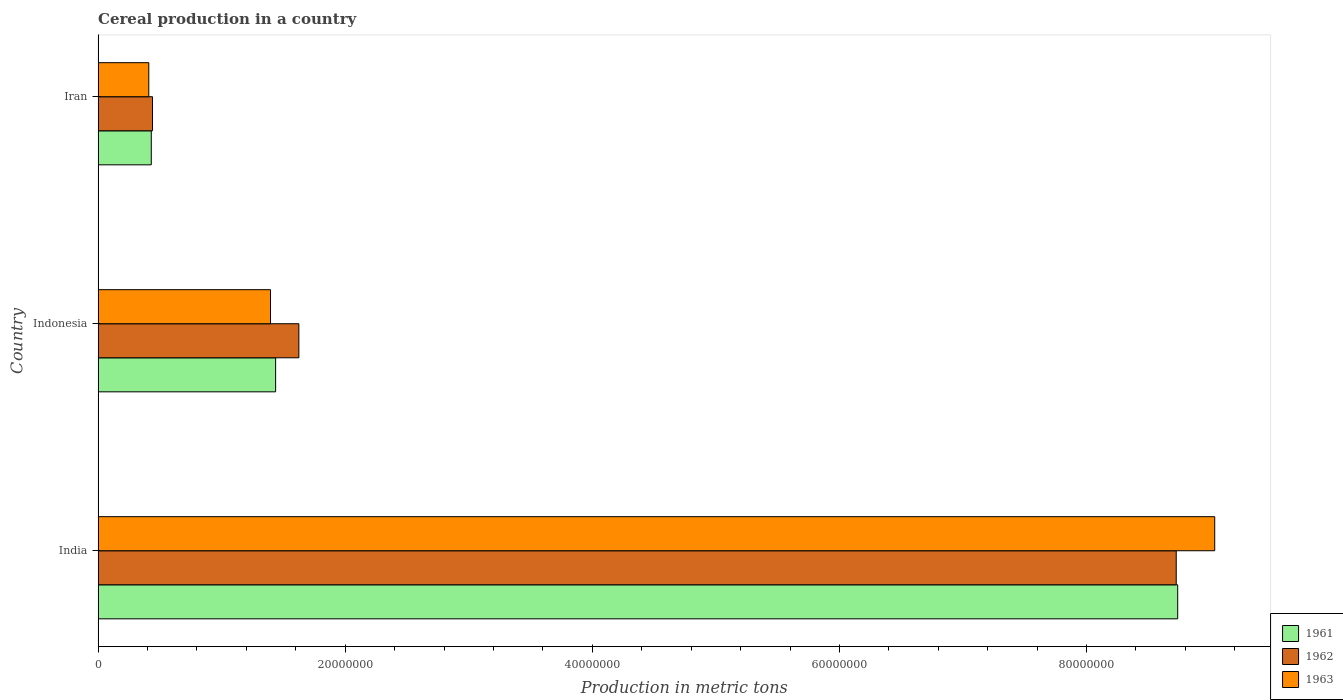How many different coloured bars are there?
Your answer should be very brief. 3. Are the number of bars on each tick of the Y-axis equal?
Provide a succinct answer. Yes. How many bars are there on the 1st tick from the top?
Make the answer very short. 3. How many bars are there on the 2nd tick from the bottom?
Offer a terse response. 3. What is the label of the 3rd group of bars from the top?
Your response must be concise. India. What is the total cereal production in 1961 in India?
Keep it short and to the point. 8.74e+07. Across all countries, what is the maximum total cereal production in 1963?
Provide a short and direct response. 9.04e+07. Across all countries, what is the minimum total cereal production in 1963?
Your answer should be very brief. 4.10e+06. In which country was the total cereal production in 1962 maximum?
Give a very brief answer. India. In which country was the total cereal production in 1962 minimum?
Provide a short and direct response. Iran. What is the total total cereal production in 1962 in the graph?
Your answer should be compact. 1.08e+08. What is the difference between the total cereal production in 1961 in India and that in Indonesia?
Make the answer very short. 7.30e+07. What is the difference between the total cereal production in 1963 in India and the total cereal production in 1962 in Indonesia?
Offer a terse response. 7.41e+07. What is the average total cereal production in 1962 per country?
Your answer should be compact. 3.60e+07. What is the difference between the total cereal production in 1962 and total cereal production in 1961 in India?
Make the answer very short. -1.19e+05. In how many countries, is the total cereal production in 1962 greater than 84000000 metric tons?
Offer a terse response. 1. What is the ratio of the total cereal production in 1963 in India to that in Indonesia?
Your answer should be compact. 6.48. Is the total cereal production in 1961 in India less than that in Indonesia?
Offer a terse response. No. Is the difference between the total cereal production in 1962 in India and Indonesia greater than the difference between the total cereal production in 1961 in India and Indonesia?
Your response must be concise. No. What is the difference between the highest and the second highest total cereal production in 1963?
Give a very brief answer. 7.64e+07. What is the difference between the highest and the lowest total cereal production in 1961?
Keep it short and to the point. 8.31e+07. In how many countries, is the total cereal production in 1962 greater than the average total cereal production in 1962 taken over all countries?
Make the answer very short. 1. Is it the case that in every country, the sum of the total cereal production in 1963 and total cereal production in 1962 is greater than the total cereal production in 1961?
Ensure brevity in your answer.  Yes. Are all the bars in the graph horizontal?
Keep it short and to the point. Yes. What is the difference between two consecutive major ticks on the X-axis?
Your answer should be compact. 2.00e+07. Are the values on the major ticks of X-axis written in scientific E-notation?
Ensure brevity in your answer.  No. Does the graph contain any zero values?
Your response must be concise. No. Where does the legend appear in the graph?
Keep it short and to the point. Bottom right. How are the legend labels stacked?
Keep it short and to the point. Vertical. What is the title of the graph?
Give a very brief answer. Cereal production in a country. What is the label or title of the X-axis?
Your answer should be compact. Production in metric tons. What is the label or title of the Y-axis?
Your answer should be compact. Country. What is the Production in metric tons in 1961 in India?
Your answer should be very brief. 8.74e+07. What is the Production in metric tons in 1962 in India?
Offer a very short reply. 8.73e+07. What is the Production in metric tons in 1963 in India?
Your response must be concise. 9.04e+07. What is the Production in metric tons in 1961 in Indonesia?
Ensure brevity in your answer.  1.44e+07. What is the Production in metric tons in 1962 in Indonesia?
Provide a short and direct response. 1.62e+07. What is the Production in metric tons of 1963 in Indonesia?
Your answer should be compact. 1.40e+07. What is the Production in metric tons of 1961 in Iran?
Offer a terse response. 4.30e+06. What is the Production in metric tons of 1962 in Iran?
Offer a terse response. 4.40e+06. What is the Production in metric tons of 1963 in Iran?
Your answer should be compact. 4.10e+06. Across all countries, what is the maximum Production in metric tons of 1961?
Ensure brevity in your answer.  8.74e+07. Across all countries, what is the maximum Production in metric tons in 1962?
Offer a very short reply. 8.73e+07. Across all countries, what is the maximum Production in metric tons in 1963?
Ensure brevity in your answer.  9.04e+07. Across all countries, what is the minimum Production in metric tons of 1961?
Make the answer very short. 4.30e+06. Across all countries, what is the minimum Production in metric tons in 1962?
Provide a succinct answer. 4.40e+06. Across all countries, what is the minimum Production in metric tons of 1963?
Give a very brief answer. 4.10e+06. What is the total Production in metric tons of 1961 in the graph?
Offer a very short reply. 1.06e+08. What is the total Production in metric tons in 1962 in the graph?
Your response must be concise. 1.08e+08. What is the total Production in metric tons in 1963 in the graph?
Provide a short and direct response. 1.08e+08. What is the difference between the Production in metric tons in 1961 in India and that in Indonesia?
Your answer should be compact. 7.30e+07. What is the difference between the Production in metric tons in 1962 in India and that in Indonesia?
Provide a short and direct response. 7.10e+07. What is the difference between the Production in metric tons in 1963 in India and that in Indonesia?
Provide a short and direct response. 7.64e+07. What is the difference between the Production in metric tons of 1961 in India and that in Iran?
Your answer should be compact. 8.31e+07. What is the difference between the Production in metric tons of 1962 in India and that in Iran?
Make the answer very short. 8.29e+07. What is the difference between the Production in metric tons in 1963 in India and that in Iran?
Make the answer very short. 8.63e+07. What is the difference between the Production in metric tons in 1961 in Indonesia and that in Iran?
Offer a very short reply. 1.01e+07. What is the difference between the Production in metric tons of 1962 in Indonesia and that in Iran?
Provide a succinct answer. 1.18e+07. What is the difference between the Production in metric tons of 1963 in Indonesia and that in Iran?
Your answer should be compact. 9.85e+06. What is the difference between the Production in metric tons in 1961 in India and the Production in metric tons in 1962 in Indonesia?
Provide a short and direct response. 7.11e+07. What is the difference between the Production in metric tons in 1961 in India and the Production in metric tons in 1963 in Indonesia?
Ensure brevity in your answer.  7.34e+07. What is the difference between the Production in metric tons in 1962 in India and the Production in metric tons in 1963 in Indonesia?
Offer a terse response. 7.33e+07. What is the difference between the Production in metric tons of 1961 in India and the Production in metric tons of 1962 in Iran?
Give a very brief answer. 8.30e+07. What is the difference between the Production in metric tons in 1961 in India and the Production in metric tons in 1963 in Iran?
Your response must be concise. 8.33e+07. What is the difference between the Production in metric tons of 1962 in India and the Production in metric tons of 1963 in Iran?
Make the answer very short. 8.32e+07. What is the difference between the Production in metric tons of 1961 in Indonesia and the Production in metric tons of 1962 in Iran?
Your answer should be very brief. 9.96e+06. What is the difference between the Production in metric tons of 1961 in Indonesia and the Production in metric tons of 1963 in Iran?
Provide a short and direct response. 1.03e+07. What is the difference between the Production in metric tons in 1962 in Indonesia and the Production in metric tons in 1963 in Iran?
Provide a short and direct response. 1.21e+07. What is the average Production in metric tons in 1961 per country?
Your answer should be compact. 3.53e+07. What is the average Production in metric tons in 1962 per country?
Make the answer very short. 3.60e+07. What is the average Production in metric tons of 1963 per country?
Offer a very short reply. 3.61e+07. What is the difference between the Production in metric tons of 1961 and Production in metric tons of 1962 in India?
Your response must be concise. 1.19e+05. What is the difference between the Production in metric tons of 1961 and Production in metric tons of 1963 in India?
Offer a terse response. -3.00e+06. What is the difference between the Production in metric tons in 1962 and Production in metric tons in 1963 in India?
Provide a short and direct response. -3.12e+06. What is the difference between the Production in metric tons of 1961 and Production in metric tons of 1962 in Indonesia?
Provide a short and direct response. -1.88e+06. What is the difference between the Production in metric tons in 1961 and Production in metric tons in 1963 in Indonesia?
Provide a succinct answer. 4.14e+05. What is the difference between the Production in metric tons of 1962 and Production in metric tons of 1963 in Indonesia?
Your answer should be very brief. 2.29e+06. What is the difference between the Production in metric tons of 1961 and Production in metric tons of 1962 in Iran?
Keep it short and to the point. -9.96e+04. What is the difference between the Production in metric tons in 1961 and Production in metric tons in 1963 in Iran?
Provide a succinct answer. 2.02e+05. What is the difference between the Production in metric tons of 1962 and Production in metric tons of 1963 in Iran?
Make the answer very short. 3.02e+05. What is the ratio of the Production in metric tons in 1961 in India to that in Indonesia?
Provide a succinct answer. 6.08. What is the ratio of the Production in metric tons of 1962 in India to that in Indonesia?
Offer a very short reply. 5.37. What is the ratio of the Production in metric tons of 1963 in India to that in Indonesia?
Provide a short and direct response. 6.48. What is the ratio of the Production in metric tons of 1961 in India to that in Iran?
Make the answer very short. 20.31. What is the ratio of the Production in metric tons in 1962 in India to that in Iran?
Provide a succinct answer. 19.82. What is the ratio of the Production in metric tons in 1963 in India to that in Iran?
Make the answer very short. 22.04. What is the ratio of the Production in metric tons in 1961 in Indonesia to that in Iran?
Your response must be concise. 3.34. What is the ratio of the Production in metric tons in 1962 in Indonesia to that in Iran?
Keep it short and to the point. 3.69. What is the ratio of the Production in metric tons in 1963 in Indonesia to that in Iran?
Give a very brief answer. 3.4. What is the difference between the highest and the second highest Production in metric tons of 1961?
Your response must be concise. 7.30e+07. What is the difference between the highest and the second highest Production in metric tons in 1962?
Your answer should be very brief. 7.10e+07. What is the difference between the highest and the second highest Production in metric tons in 1963?
Give a very brief answer. 7.64e+07. What is the difference between the highest and the lowest Production in metric tons in 1961?
Provide a short and direct response. 8.31e+07. What is the difference between the highest and the lowest Production in metric tons in 1962?
Ensure brevity in your answer.  8.29e+07. What is the difference between the highest and the lowest Production in metric tons in 1963?
Your response must be concise. 8.63e+07. 